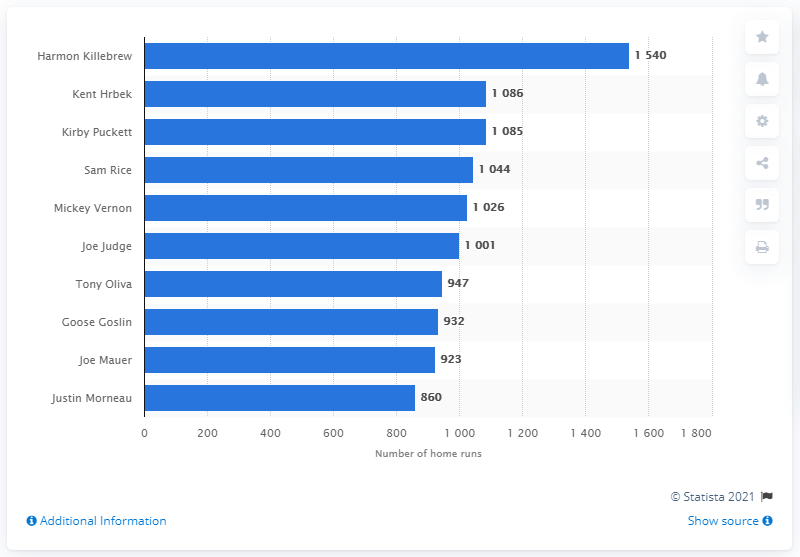Point out several critical features in this image. Harmon Killebrew holds the record for the most RBI in the history of the Minnesota Twins franchise. 